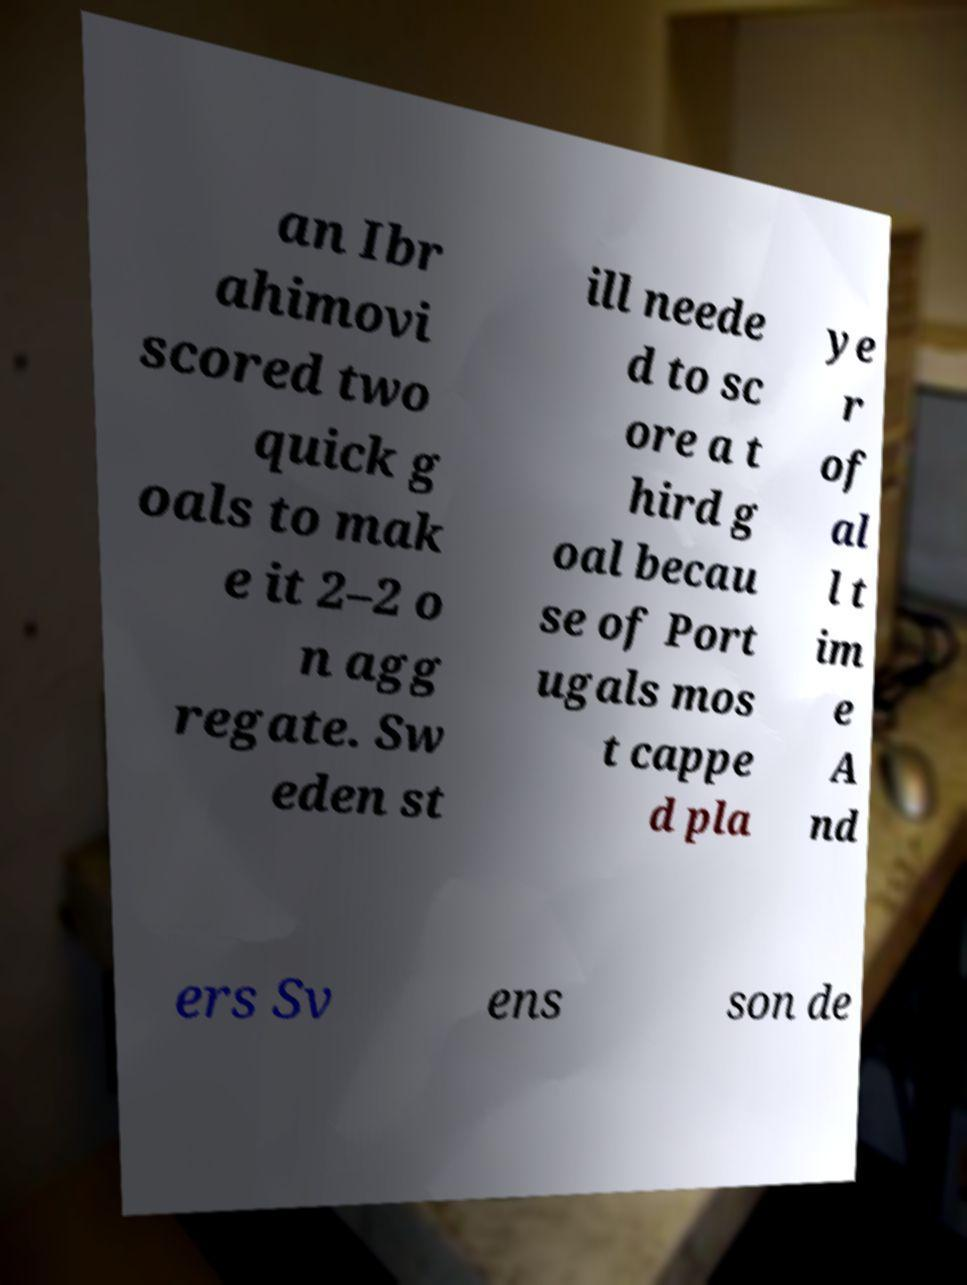For documentation purposes, I need the text within this image transcribed. Could you provide that? an Ibr ahimovi scored two quick g oals to mak e it 2–2 o n agg regate. Sw eden st ill neede d to sc ore a t hird g oal becau se of Port ugals mos t cappe d pla ye r of al l t im e A nd ers Sv ens son de 